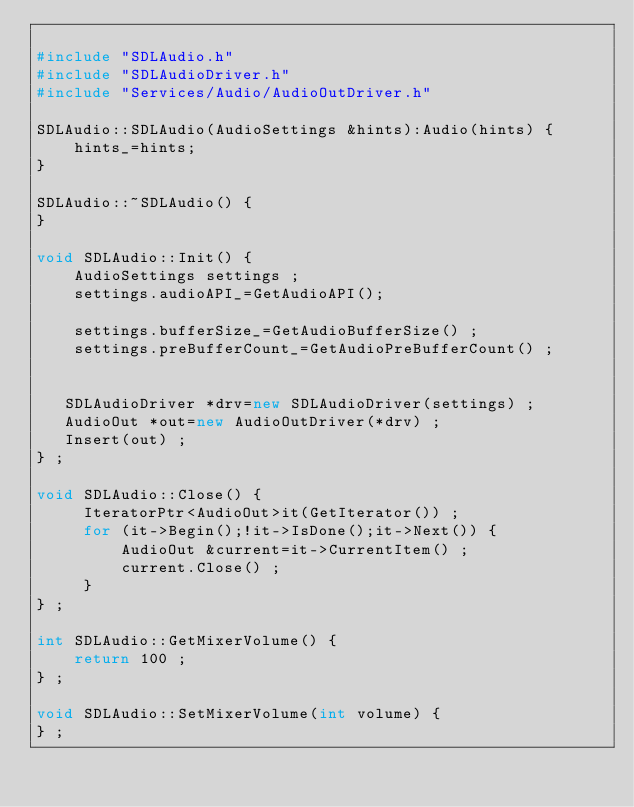Convert code to text. <code><loc_0><loc_0><loc_500><loc_500><_C++_>
#include "SDLAudio.h"
#include "SDLAudioDriver.h"
#include "Services/Audio/AudioOutDriver.h"

SDLAudio::SDLAudio(AudioSettings &hints):Audio(hints) {
	hints_=hints;
}

SDLAudio::~SDLAudio() {
}

void SDLAudio::Init() {
	AudioSettings settings ;
	settings.audioAPI_=GetAudioAPI();

	settings.bufferSize_=GetAudioBufferSize() ;
	settings.preBufferCount_=GetAudioPreBufferCount() ;


   SDLAudioDriver *drv=new SDLAudioDriver(settings) ;
   AudioOut *out=new AudioOutDriver(*drv) ;
   Insert(out) ;
} ;

void SDLAudio::Close() {
     IteratorPtr<AudioOut>it(GetIterator()) ;
     for (it->Begin();!it->IsDone();it->Next()) {
         AudioOut &current=it->CurrentItem() ;
         current.Close() ;
     }
} ;

int SDLAudio::GetMixerVolume() {
	return 100 ;
} ;

void SDLAudio::SetMixerVolume(int volume) {
} ;
</code> 